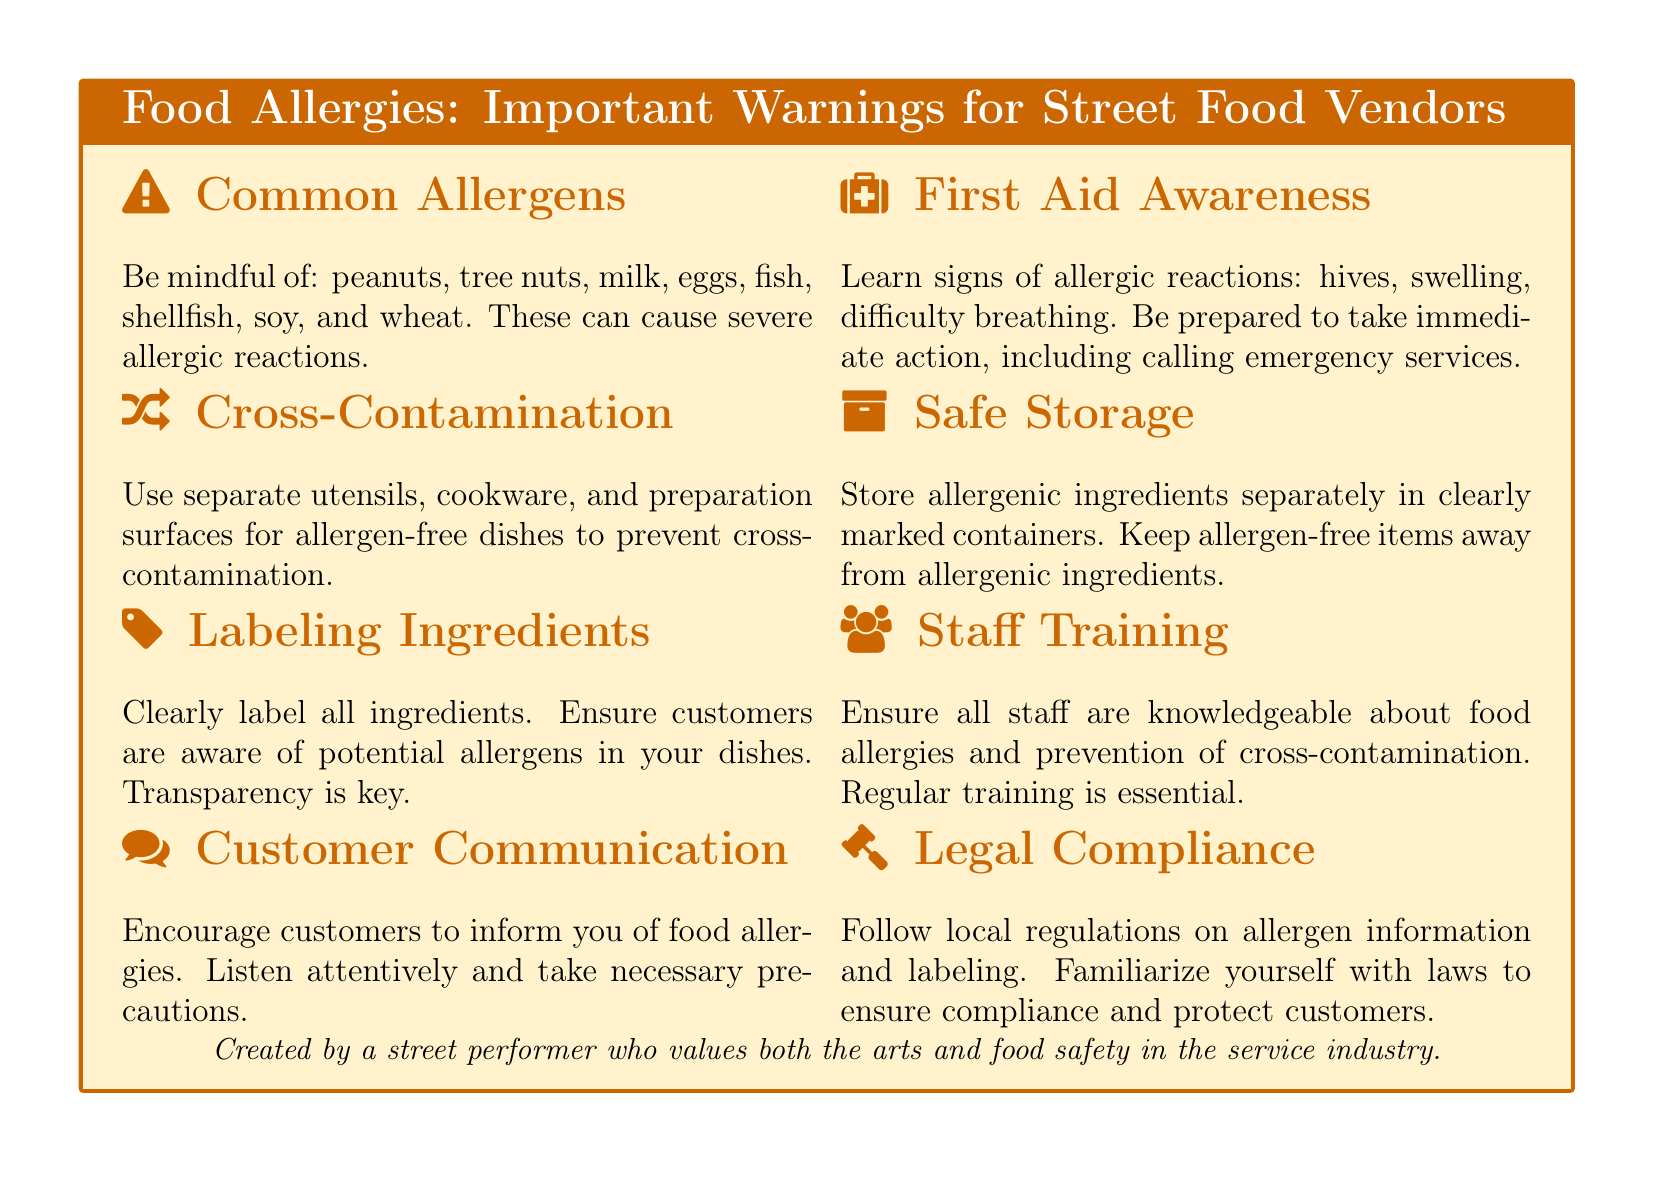What are the common allergens listed? The document explicitly mentions common allergens that street food vendors should be mindful of, which include peanuts, tree nuts, milk, eggs, fish, shellfish, soy, and wheat.
Answer: peanuts, tree nuts, milk, eggs, fish, shellfish, soy, and wheat What does the document say about cross-contamination? It emphasizes the importance of using separate utensils, cookware, and preparation surfaces for allergen-free dishes to prevent cross-contamination among ingredients.
Answer: Prevent cross-contamination What should vendors encourage customers to do? The document suggests that vendors should encourage customers to inform them of any food allergies to ensure safety and proper precautions.
Answer: Inform of food allergies What signs of allergic reactions should vendors learn? It lists crucial signs such as hives, swelling, and difficulty breathing that indicate an allergic reaction, prompting the need for immediate action.
Answer: Hives, swelling, difficulty breathing What is required for staff training? The document states that all staff must be knowledgeable about food allergies and prevention of cross-contamination, indicating a focus on regular training.
Answer: Knowledgeable about food allergies How should allergenic ingredients be stored? Ingredients that may cause allergies should be stored separately in clearly marked containers, according to the safety guidelines for vendors.
Answer: Clearly marked containers What does the document emphasize about labeling ingredients? It insists on the importance of clearly labeling all ingredients to ensure customers are aware of potential allergens.
Answer: Clearly label all ingredients What is needed for legal compliance? Familiarity with local regulations on allergen information and labeling is necessary for vendors to comply with legal requirements and ensure customer safety.
Answer: Local regulations on allergen information What is the purpose of this document? This document serves as a warning label, providing essential information and precautions about food allergies specifically for street food vendors.
Answer: Important warnings for street food vendors 